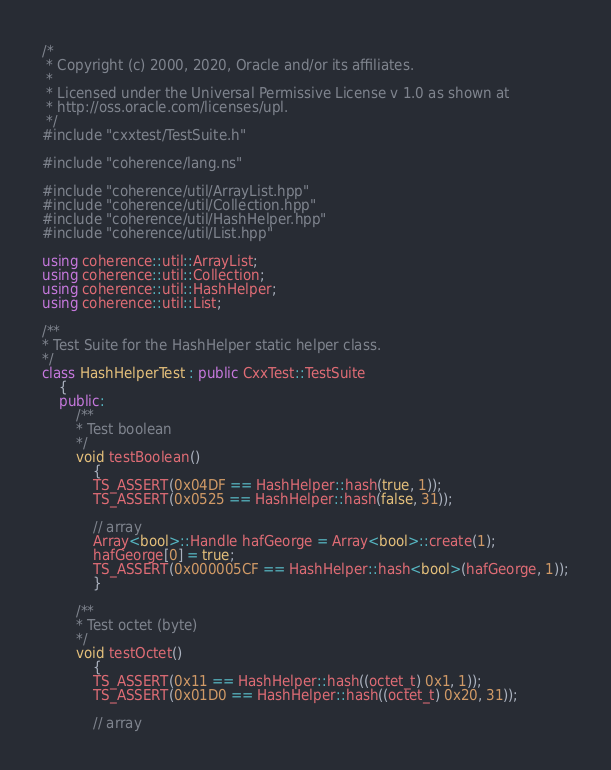Convert code to text. <code><loc_0><loc_0><loc_500><loc_500><_C++_>/*
 * Copyright (c) 2000, 2020, Oracle and/or its affiliates.
 *
 * Licensed under the Universal Permissive License v 1.0 as shown at
 * http://oss.oracle.com/licenses/upl.
 */
#include "cxxtest/TestSuite.h"

#include "coherence/lang.ns"

#include "coherence/util/ArrayList.hpp"
#include "coherence/util/Collection.hpp"
#include "coherence/util/HashHelper.hpp"
#include "coherence/util/List.hpp"

using coherence::util::ArrayList;
using coherence::util::Collection;
using coherence::util::HashHelper;
using coherence::util::List;

/**
* Test Suite for the HashHelper static helper class.
*/
class HashHelperTest : public CxxTest::TestSuite
    {
    public:
        /**
        * Test boolean
        */
        void testBoolean()
            {
            TS_ASSERT(0x04DF == HashHelper::hash(true, 1));
            TS_ASSERT(0x0525 == HashHelper::hash(false, 31));

            // array
            Array<bool>::Handle hafGeorge = Array<bool>::create(1);
            hafGeorge[0] = true;
            TS_ASSERT(0x000005CF == HashHelper::hash<bool>(hafGeorge, 1));
            }

        /**
        * Test octet (byte)
        */
        void testOctet()
            {
            TS_ASSERT(0x11 == HashHelper::hash((octet_t) 0x1, 1));
            TS_ASSERT(0x01D0 == HashHelper::hash((octet_t) 0x20, 31));

            // array</code> 